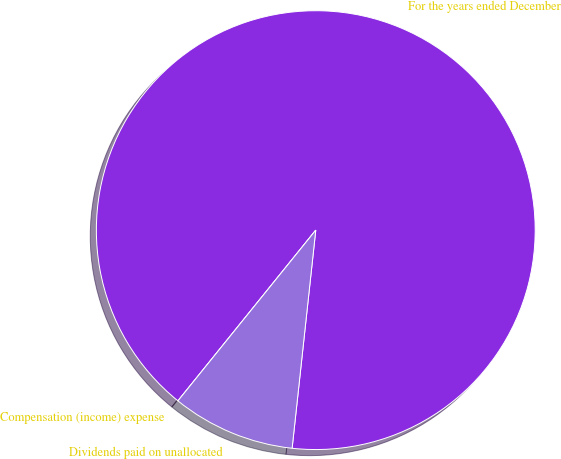Convert chart to OTSL. <chart><loc_0><loc_0><loc_500><loc_500><pie_chart><fcel>For the years ended December<fcel>Compensation (income) expense<fcel>Dividends paid on unallocated<nl><fcel>90.9%<fcel>0.0%<fcel>9.09%<nl></chart> 